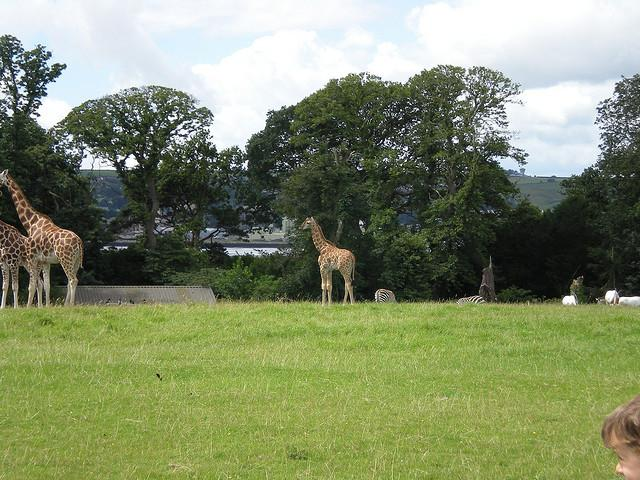What are the zebras doing? grazing 